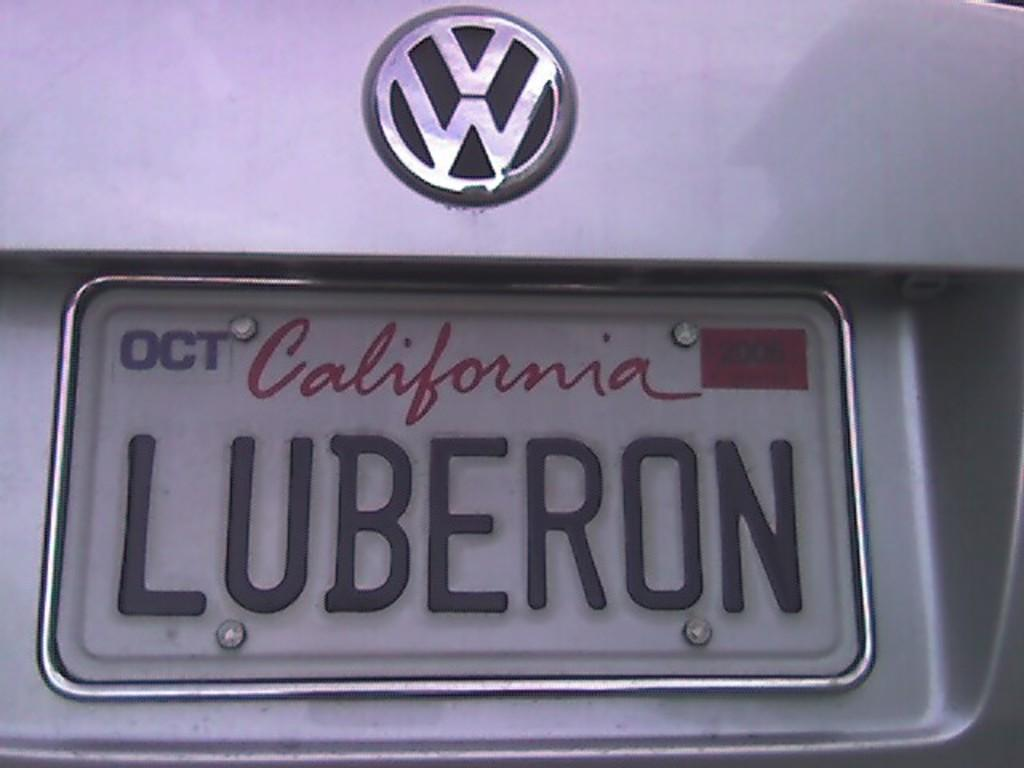<image>
Give a short and clear explanation of the subsequent image. A personalized California license plate has LUBERON on it. 